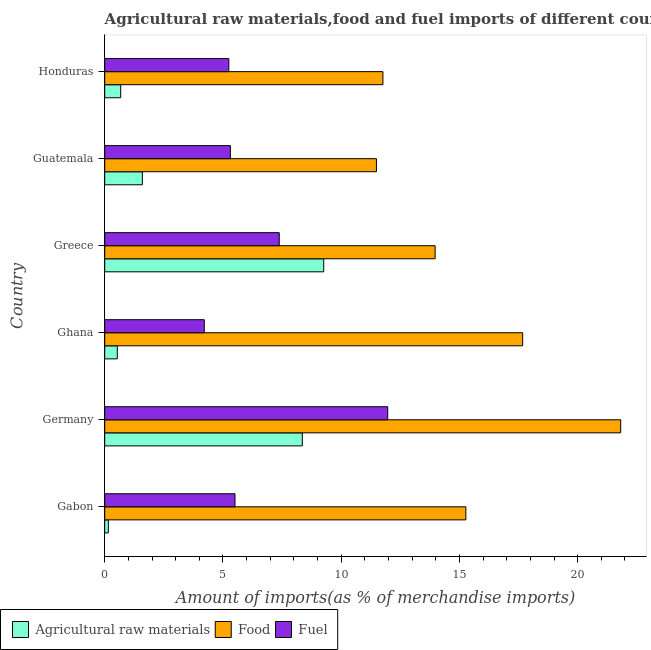Are the number of bars per tick equal to the number of legend labels?
Offer a terse response. Yes. Are the number of bars on each tick of the Y-axis equal?
Provide a short and direct response. Yes. What is the percentage of fuel imports in Ghana?
Keep it short and to the point. 4.21. Across all countries, what is the maximum percentage of raw materials imports?
Give a very brief answer. 9.26. Across all countries, what is the minimum percentage of food imports?
Your response must be concise. 11.49. In which country was the percentage of food imports minimum?
Make the answer very short. Guatemala. What is the total percentage of food imports in the graph?
Provide a succinct answer. 91.99. What is the difference between the percentage of fuel imports in Gabon and that in Honduras?
Provide a short and direct response. 0.26. What is the difference between the percentage of fuel imports in Guatemala and the percentage of food imports in Ghana?
Your answer should be very brief. -12.36. What is the average percentage of raw materials imports per country?
Make the answer very short. 3.43. What is the difference between the percentage of raw materials imports and percentage of fuel imports in Gabon?
Keep it short and to the point. -5.36. In how many countries, is the percentage of raw materials imports greater than 21 %?
Offer a very short reply. 0. What is the ratio of the percentage of raw materials imports in Gabon to that in Honduras?
Your answer should be compact. 0.23. Is the percentage of food imports in Guatemala less than that in Honduras?
Ensure brevity in your answer.  Yes. What is the difference between the highest and the second highest percentage of fuel imports?
Provide a short and direct response. 4.59. What is the difference between the highest and the lowest percentage of raw materials imports?
Provide a succinct answer. 9.11. In how many countries, is the percentage of raw materials imports greater than the average percentage of raw materials imports taken over all countries?
Give a very brief answer. 2. Is the sum of the percentage of fuel imports in Guatemala and Honduras greater than the maximum percentage of food imports across all countries?
Provide a short and direct response. No. What does the 3rd bar from the top in Gabon represents?
Keep it short and to the point. Agricultural raw materials. What does the 2nd bar from the bottom in Ghana represents?
Provide a succinct answer. Food. How many bars are there?
Your answer should be very brief. 18. How many countries are there in the graph?
Your response must be concise. 6. What is the difference between two consecutive major ticks on the X-axis?
Give a very brief answer. 5. Does the graph contain grids?
Offer a very short reply. No. Where does the legend appear in the graph?
Offer a terse response. Bottom left. What is the title of the graph?
Provide a short and direct response. Agricultural raw materials,food and fuel imports of different countries in 1966. Does "Slovak Republic" appear as one of the legend labels in the graph?
Your answer should be very brief. No. What is the label or title of the X-axis?
Ensure brevity in your answer.  Amount of imports(as % of merchandise imports). What is the label or title of the Y-axis?
Provide a succinct answer. Country. What is the Amount of imports(as % of merchandise imports) of Agricultural raw materials in Gabon?
Give a very brief answer. 0.15. What is the Amount of imports(as % of merchandise imports) in Food in Gabon?
Your answer should be compact. 15.27. What is the Amount of imports(as % of merchandise imports) in Fuel in Gabon?
Offer a very short reply. 5.51. What is the Amount of imports(as % of merchandise imports) in Agricultural raw materials in Germany?
Give a very brief answer. 8.36. What is the Amount of imports(as % of merchandise imports) in Food in Germany?
Provide a short and direct response. 21.82. What is the Amount of imports(as % of merchandise imports) in Fuel in Germany?
Offer a very short reply. 11.97. What is the Amount of imports(as % of merchandise imports) in Agricultural raw materials in Ghana?
Offer a terse response. 0.53. What is the Amount of imports(as % of merchandise imports) of Food in Ghana?
Provide a short and direct response. 17.67. What is the Amount of imports(as % of merchandise imports) of Fuel in Ghana?
Give a very brief answer. 4.21. What is the Amount of imports(as % of merchandise imports) of Agricultural raw materials in Greece?
Your answer should be compact. 9.26. What is the Amount of imports(as % of merchandise imports) in Food in Greece?
Make the answer very short. 13.97. What is the Amount of imports(as % of merchandise imports) of Fuel in Greece?
Provide a short and direct response. 7.38. What is the Amount of imports(as % of merchandise imports) of Agricultural raw materials in Guatemala?
Offer a very short reply. 1.59. What is the Amount of imports(as % of merchandise imports) of Food in Guatemala?
Ensure brevity in your answer.  11.49. What is the Amount of imports(as % of merchandise imports) in Fuel in Guatemala?
Provide a short and direct response. 5.31. What is the Amount of imports(as % of merchandise imports) in Agricultural raw materials in Honduras?
Keep it short and to the point. 0.68. What is the Amount of imports(as % of merchandise imports) in Food in Honduras?
Your answer should be compact. 11.76. What is the Amount of imports(as % of merchandise imports) of Fuel in Honduras?
Keep it short and to the point. 5.25. Across all countries, what is the maximum Amount of imports(as % of merchandise imports) in Agricultural raw materials?
Give a very brief answer. 9.26. Across all countries, what is the maximum Amount of imports(as % of merchandise imports) of Food?
Your answer should be very brief. 21.82. Across all countries, what is the maximum Amount of imports(as % of merchandise imports) of Fuel?
Provide a succinct answer. 11.97. Across all countries, what is the minimum Amount of imports(as % of merchandise imports) of Agricultural raw materials?
Offer a very short reply. 0.15. Across all countries, what is the minimum Amount of imports(as % of merchandise imports) of Food?
Your answer should be compact. 11.49. Across all countries, what is the minimum Amount of imports(as % of merchandise imports) in Fuel?
Your response must be concise. 4.21. What is the total Amount of imports(as % of merchandise imports) in Agricultural raw materials in the graph?
Make the answer very short. 20.57. What is the total Amount of imports(as % of merchandise imports) of Food in the graph?
Your answer should be compact. 91.99. What is the total Amount of imports(as % of merchandise imports) in Fuel in the graph?
Your answer should be very brief. 39.63. What is the difference between the Amount of imports(as % of merchandise imports) of Agricultural raw materials in Gabon and that in Germany?
Offer a very short reply. -8.2. What is the difference between the Amount of imports(as % of merchandise imports) in Food in Gabon and that in Germany?
Your response must be concise. -6.55. What is the difference between the Amount of imports(as % of merchandise imports) in Fuel in Gabon and that in Germany?
Your answer should be very brief. -6.46. What is the difference between the Amount of imports(as % of merchandise imports) in Agricultural raw materials in Gabon and that in Ghana?
Keep it short and to the point. -0.38. What is the difference between the Amount of imports(as % of merchandise imports) of Food in Gabon and that in Ghana?
Ensure brevity in your answer.  -2.4. What is the difference between the Amount of imports(as % of merchandise imports) of Fuel in Gabon and that in Ghana?
Offer a very short reply. 1.3. What is the difference between the Amount of imports(as % of merchandise imports) of Agricultural raw materials in Gabon and that in Greece?
Provide a short and direct response. -9.11. What is the difference between the Amount of imports(as % of merchandise imports) in Food in Gabon and that in Greece?
Your answer should be very brief. 1.3. What is the difference between the Amount of imports(as % of merchandise imports) in Fuel in Gabon and that in Greece?
Your answer should be very brief. -1.87. What is the difference between the Amount of imports(as % of merchandise imports) in Agricultural raw materials in Gabon and that in Guatemala?
Provide a succinct answer. -1.44. What is the difference between the Amount of imports(as % of merchandise imports) in Food in Gabon and that in Guatemala?
Offer a terse response. 3.78. What is the difference between the Amount of imports(as % of merchandise imports) in Fuel in Gabon and that in Guatemala?
Keep it short and to the point. 0.2. What is the difference between the Amount of imports(as % of merchandise imports) of Agricultural raw materials in Gabon and that in Honduras?
Ensure brevity in your answer.  -0.52. What is the difference between the Amount of imports(as % of merchandise imports) of Food in Gabon and that in Honduras?
Keep it short and to the point. 3.51. What is the difference between the Amount of imports(as % of merchandise imports) in Fuel in Gabon and that in Honduras?
Make the answer very short. 0.26. What is the difference between the Amount of imports(as % of merchandise imports) of Agricultural raw materials in Germany and that in Ghana?
Provide a succinct answer. 7.82. What is the difference between the Amount of imports(as % of merchandise imports) of Food in Germany and that in Ghana?
Offer a very short reply. 4.14. What is the difference between the Amount of imports(as % of merchandise imports) in Fuel in Germany and that in Ghana?
Provide a succinct answer. 7.76. What is the difference between the Amount of imports(as % of merchandise imports) of Agricultural raw materials in Germany and that in Greece?
Your answer should be compact. -0.91. What is the difference between the Amount of imports(as % of merchandise imports) in Food in Germany and that in Greece?
Your answer should be compact. 7.85. What is the difference between the Amount of imports(as % of merchandise imports) in Fuel in Germany and that in Greece?
Provide a short and direct response. 4.59. What is the difference between the Amount of imports(as % of merchandise imports) of Agricultural raw materials in Germany and that in Guatemala?
Offer a very short reply. 6.76. What is the difference between the Amount of imports(as % of merchandise imports) in Food in Germany and that in Guatemala?
Your answer should be compact. 10.33. What is the difference between the Amount of imports(as % of merchandise imports) of Fuel in Germany and that in Guatemala?
Your answer should be very brief. 6.65. What is the difference between the Amount of imports(as % of merchandise imports) of Agricultural raw materials in Germany and that in Honduras?
Give a very brief answer. 7.68. What is the difference between the Amount of imports(as % of merchandise imports) in Food in Germany and that in Honduras?
Your response must be concise. 10.05. What is the difference between the Amount of imports(as % of merchandise imports) in Fuel in Germany and that in Honduras?
Your answer should be very brief. 6.72. What is the difference between the Amount of imports(as % of merchandise imports) in Agricultural raw materials in Ghana and that in Greece?
Provide a short and direct response. -8.73. What is the difference between the Amount of imports(as % of merchandise imports) in Food in Ghana and that in Greece?
Provide a succinct answer. 3.7. What is the difference between the Amount of imports(as % of merchandise imports) in Fuel in Ghana and that in Greece?
Your answer should be very brief. -3.17. What is the difference between the Amount of imports(as % of merchandise imports) in Agricultural raw materials in Ghana and that in Guatemala?
Make the answer very short. -1.06. What is the difference between the Amount of imports(as % of merchandise imports) of Food in Ghana and that in Guatemala?
Give a very brief answer. 6.18. What is the difference between the Amount of imports(as % of merchandise imports) in Fuel in Ghana and that in Guatemala?
Ensure brevity in your answer.  -1.1. What is the difference between the Amount of imports(as % of merchandise imports) in Agricultural raw materials in Ghana and that in Honduras?
Make the answer very short. -0.14. What is the difference between the Amount of imports(as % of merchandise imports) in Food in Ghana and that in Honduras?
Make the answer very short. 5.91. What is the difference between the Amount of imports(as % of merchandise imports) in Fuel in Ghana and that in Honduras?
Ensure brevity in your answer.  -1.04. What is the difference between the Amount of imports(as % of merchandise imports) of Agricultural raw materials in Greece and that in Guatemala?
Offer a very short reply. 7.67. What is the difference between the Amount of imports(as % of merchandise imports) in Food in Greece and that in Guatemala?
Make the answer very short. 2.48. What is the difference between the Amount of imports(as % of merchandise imports) of Fuel in Greece and that in Guatemala?
Provide a succinct answer. 2.07. What is the difference between the Amount of imports(as % of merchandise imports) in Agricultural raw materials in Greece and that in Honduras?
Make the answer very short. 8.59. What is the difference between the Amount of imports(as % of merchandise imports) of Food in Greece and that in Honduras?
Ensure brevity in your answer.  2.21. What is the difference between the Amount of imports(as % of merchandise imports) of Fuel in Greece and that in Honduras?
Your response must be concise. 2.13. What is the difference between the Amount of imports(as % of merchandise imports) in Agricultural raw materials in Guatemala and that in Honduras?
Make the answer very short. 0.92. What is the difference between the Amount of imports(as % of merchandise imports) in Food in Guatemala and that in Honduras?
Your answer should be compact. -0.28. What is the difference between the Amount of imports(as % of merchandise imports) in Fuel in Guatemala and that in Honduras?
Provide a succinct answer. 0.06. What is the difference between the Amount of imports(as % of merchandise imports) in Agricultural raw materials in Gabon and the Amount of imports(as % of merchandise imports) in Food in Germany?
Provide a succinct answer. -21.67. What is the difference between the Amount of imports(as % of merchandise imports) of Agricultural raw materials in Gabon and the Amount of imports(as % of merchandise imports) of Fuel in Germany?
Offer a terse response. -11.81. What is the difference between the Amount of imports(as % of merchandise imports) in Food in Gabon and the Amount of imports(as % of merchandise imports) in Fuel in Germany?
Give a very brief answer. 3.3. What is the difference between the Amount of imports(as % of merchandise imports) in Agricultural raw materials in Gabon and the Amount of imports(as % of merchandise imports) in Food in Ghana?
Provide a short and direct response. -17.52. What is the difference between the Amount of imports(as % of merchandise imports) of Agricultural raw materials in Gabon and the Amount of imports(as % of merchandise imports) of Fuel in Ghana?
Make the answer very short. -4.06. What is the difference between the Amount of imports(as % of merchandise imports) in Food in Gabon and the Amount of imports(as % of merchandise imports) in Fuel in Ghana?
Give a very brief answer. 11.06. What is the difference between the Amount of imports(as % of merchandise imports) of Agricultural raw materials in Gabon and the Amount of imports(as % of merchandise imports) of Food in Greece?
Give a very brief answer. -13.82. What is the difference between the Amount of imports(as % of merchandise imports) in Agricultural raw materials in Gabon and the Amount of imports(as % of merchandise imports) in Fuel in Greece?
Offer a very short reply. -7.23. What is the difference between the Amount of imports(as % of merchandise imports) of Food in Gabon and the Amount of imports(as % of merchandise imports) of Fuel in Greece?
Your answer should be compact. 7.89. What is the difference between the Amount of imports(as % of merchandise imports) of Agricultural raw materials in Gabon and the Amount of imports(as % of merchandise imports) of Food in Guatemala?
Keep it short and to the point. -11.34. What is the difference between the Amount of imports(as % of merchandise imports) of Agricultural raw materials in Gabon and the Amount of imports(as % of merchandise imports) of Fuel in Guatemala?
Make the answer very short. -5.16. What is the difference between the Amount of imports(as % of merchandise imports) in Food in Gabon and the Amount of imports(as % of merchandise imports) in Fuel in Guatemala?
Your answer should be compact. 9.96. What is the difference between the Amount of imports(as % of merchandise imports) in Agricultural raw materials in Gabon and the Amount of imports(as % of merchandise imports) in Food in Honduras?
Give a very brief answer. -11.61. What is the difference between the Amount of imports(as % of merchandise imports) in Agricultural raw materials in Gabon and the Amount of imports(as % of merchandise imports) in Fuel in Honduras?
Offer a terse response. -5.09. What is the difference between the Amount of imports(as % of merchandise imports) in Food in Gabon and the Amount of imports(as % of merchandise imports) in Fuel in Honduras?
Make the answer very short. 10.02. What is the difference between the Amount of imports(as % of merchandise imports) in Agricultural raw materials in Germany and the Amount of imports(as % of merchandise imports) in Food in Ghana?
Keep it short and to the point. -9.32. What is the difference between the Amount of imports(as % of merchandise imports) in Agricultural raw materials in Germany and the Amount of imports(as % of merchandise imports) in Fuel in Ghana?
Your response must be concise. 4.15. What is the difference between the Amount of imports(as % of merchandise imports) of Food in Germany and the Amount of imports(as % of merchandise imports) of Fuel in Ghana?
Give a very brief answer. 17.61. What is the difference between the Amount of imports(as % of merchandise imports) of Agricultural raw materials in Germany and the Amount of imports(as % of merchandise imports) of Food in Greece?
Give a very brief answer. -5.62. What is the difference between the Amount of imports(as % of merchandise imports) in Agricultural raw materials in Germany and the Amount of imports(as % of merchandise imports) in Fuel in Greece?
Your response must be concise. 0.97. What is the difference between the Amount of imports(as % of merchandise imports) in Food in Germany and the Amount of imports(as % of merchandise imports) in Fuel in Greece?
Offer a very short reply. 14.44. What is the difference between the Amount of imports(as % of merchandise imports) in Agricultural raw materials in Germany and the Amount of imports(as % of merchandise imports) in Food in Guatemala?
Your answer should be compact. -3.13. What is the difference between the Amount of imports(as % of merchandise imports) of Agricultural raw materials in Germany and the Amount of imports(as % of merchandise imports) of Fuel in Guatemala?
Your answer should be very brief. 3.04. What is the difference between the Amount of imports(as % of merchandise imports) in Food in Germany and the Amount of imports(as % of merchandise imports) in Fuel in Guatemala?
Offer a very short reply. 16.51. What is the difference between the Amount of imports(as % of merchandise imports) in Agricultural raw materials in Germany and the Amount of imports(as % of merchandise imports) in Food in Honduras?
Make the answer very short. -3.41. What is the difference between the Amount of imports(as % of merchandise imports) in Agricultural raw materials in Germany and the Amount of imports(as % of merchandise imports) in Fuel in Honduras?
Make the answer very short. 3.11. What is the difference between the Amount of imports(as % of merchandise imports) in Food in Germany and the Amount of imports(as % of merchandise imports) in Fuel in Honduras?
Offer a terse response. 16.57. What is the difference between the Amount of imports(as % of merchandise imports) of Agricultural raw materials in Ghana and the Amount of imports(as % of merchandise imports) of Food in Greece?
Offer a very short reply. -13.44. What is the difference between the Amount of imports(as % of merchandise imports) in Agricultural raw materials in Ghana and the Amount of imports(as % of merchandise imports) in Fuel in Greece?
Provide a short and direct response. -6.85. What is the difference between the Amount of imports(as % of merchandise imports) of Food in Ghana and the Amount of imports(as % of merchandise imports) of Fuel in Greece?
Provide a short and direct response. 10.29. What is the difference between the Amount of imports(as % of merchandise imports) of Agricultural raw materials in Ghana and the Amount of imports(as % of merchandise imports) of Food in Guatemala?
Offer a very short reply. -10.96. What is the difference between the Amount of imports(as % of merchandise imports) of Agricultural raw materials in Ghana and the Amount of imports(as % of merchandise imports) of Fuel in Guatemala?
Your answer should be compact. -4.78. What is the difference between the Amount of imports(as % of merchandise imports) in Food in Ghana and the Amount of imports(as % of merchandise imports) in Fuel in Guatemala?
Keep it short and to the point. 12.36. What is the difference between the Amount of imports(as % of merchandise imports) in Agricultural raw materials in Ghana and the Amount of imports(as % of merchandise imports) in Food in Honduras?
Offer a terse response. -11.23. What is the difference between the Amount of imports(as % of merchandise imports) in Agricultural raw materials in Ghana and the Amount of imports(as % of merchandise imports) in Fuel in Honduras?
Your answer should be very brief. -4.72. What is the difference between the Amount of imports(as % of merchandise imports) in Food in Ghana and the Amount of imports(as % of merchandise imports) in Fuel in Honduras?
Provide a succinct answer. 12.43. What is the difference between the Amount of imports(as % of merchandise imports) of Agricultural raw materials in Greece and the Amount of imports(as % of merchandise imports) of Food in Guatemala?
Offer a very short reply. -2.23. What is the difference between the Amount of imports(as % of merchandise imports) in Agricultural raw materials in Greece and the Amount of imports(as % of merchandise imports) in Fuel in Guatemala?
Offer a very short reply. 3.95. What is the difference between the Amount of imports(as % of merchandise imports) in Food in Greece and the Amount of imports(as % of merchandise imports) in Fuel in Guatemala?
Give a very brief answer. 8.66. What is the difference between the Amount of imports(as % of merchandise imports) in Agricultural raw materials in Greece and the Amount of imports(as % of merchandise imports) in Food in Honduras?
Your response must be concise. -2.5. What is the difference between the Amount of imports(as % of merchandise imports) in Agricultural raw materials in Greece and the Amount of imports(as % of merchandise imports) in Fuel in Honduras?
Ensure brevity in your answer.  4.01. What is the difference between the Amount of imports(as % of merchandise imports) of Food in Greece and the Amount of imports(as % of merchandise imports) of Fuel in Honduras?
Keep it short and to the point. 8.72. What is the difference between the Amount of imports(as % of merchandise imports) in Agricultural raw materials in Guatemala and the Amount of imports(as % of merchandise imports) in Food in Honduras?
Ensure brevity in your answer.  -10.17. What is the difference between the Amount of imports(as % of merchandise imports) in Agricultural raw materials in Guatemala and the Amount of imports(as % of merchandise imports) in Fuel in Honduras?
Offer a terse response. -3.66. What is the difference between the Amount of imports(as % of merchandise imports) of Food in Guatemala and the Amount of imports(as % of merchandise imports) of Fuel in Honduras?
Offer a terse response. 6.24. What is the average Amount of imports(as % of merchandise imports) of Agricultural raw materials per country?
Keep it short and to the point. 3.43. What is the average Amount of imports(as % of merchandise imports) in Food per country?
Your response must be concise. 15.33. What is the average Amount of imports(as % of merchandise imports) in Fuel per country?
Provide a succinct answer. 6.6. What is the difference between the Amount of imports(as % of merchandise imports) of Agricultural raw materials and Amount of imports(as % of merchandise imports) of Food in Gabon?
Your answer should be very brief. -15.12. What is the difference between the Amount of imports(as % of merchandise imports) in Agricultural raw materials and Amount of imports(as % of merchandise imports) in Fuel in Gabon?
Keep it short and to the point. -5.36. What is the difference between the Amount of imports(as % of merchandise imports) of Food and Amount of imports(as % of merchandise imports) of Fuel in Gabon?
Keep it short and to the point. 9.76. What is the difference between the Amount of imports(as % of merchandise imports) in Agricultural raw materials and Amount of imports(as % of merchandise imports) in Food in Germany?
Offer a very short reply. -13.46. What is the difference between the Amount of imports(as % of merchandise imports) in Agricultural raw materials and Amount of imports(as % of merchandise imports) in Fuel in Germany?
Make the answer very short. -3.61. What is the difference between the Amount of imports(as % of merchandise imports) in Food and Amount of imports(as % of merchandise imports) in Fuel in Germany?
Give a very brief answer. 9.85. What is the difference between the Amount of imports(as % of merchandise imports) in Agricultural raw materials and Amount of imports(as % of merchandise imports) in Food in Ghana?
Your answer should be very brief. -17.14. What is the difference between the Amount of imports(as % of merchandise imports) of Agricultural raw materials and Amount of imports(as % of merchandise imports) of Fuel in Ghana?
Offer a terse response. -3.68. What is the difference between the Amount of imports(as % of merchandise imports) in Food and Amount of imports(as % of merchandise imports) in Fuel in Ghana?
Your answer should be compact. 13.46. What is the difference between the Amount of imports(as % of merchandise imports) in Agricultural raw materials and Amount of imports(as % of merchandise imports) in Food in Greece?
Your response must be concise. -4.71. What is the difference between the Amount of imports(as % of merchandise imports) of Agricultural raw materials and Amount of imports(as % of merchandise imports) of Fuel in Greece?
Make the answer very short. 1.88. What is the difference between the Amount of imports(as % of merchandise imports) in Food and Amount of imports(as % of merchandise imports) in Fuel in Greece?
Your answer should be very brief. 6.59. What is the difference between the Amount of imports(as % of merchandise imports) of Agricultural raw materials and Amount of imports(as % of merchandise imports) of Food in Guatemala?
Your answer should be very brief. -9.9. What is the difference between the Amount of imports(as % of merchandise imports) in Agricultural raw materials and Amount of imports(as % of merchandise imports) in Fuel in Guatemala?
Provide a short and direct response. -3.72. What is the difference between the Amount of imports(as % of merchandise imports) in Food and Amount of imports(as % of merchandise imports) in Fuel in Guatemala?
Give a very brief answer. 6.18. What is the difference between the Amount of imports(as % of merchandise imports) of Agricultural raw materials and Amount of imports(as % of merchandise imports) of Food in Honduras?
Your response must be concise. -11.09. What is the difference between the Amount of imports(as % of merchandise imports) of Agricultural raw materials and Amount of imports(as % of merchandise imports) of Fuel in Honduras?
Ensure brevity in your answer.  -4.57. What is the difference between the Amount of imports(as % of merchandise imports) of Food and Amount of imports(as % of merchandise imports) of Fuel in Honduras?
Provide a succinct answer. 6.52. What is the ratio of the Amount of imports(as % of merchandise imports) in Agricultural raw materials in Gabon to that in Germany?
Provide a short and direct response. 0.02. What is the ratio of the Amount of imports(as % of merchandise imports) of Food in Gabon to that in Germany?
Ensure brevity in your answer.  0.7. What is the ratio of the Amount of imports(as % of merchandise imports) of Fuel in Gabon to that in Germany?
Give a very brief answer. 0.46. What is the ratio of the Amount of imports(as % of merchandise imports) in Agricultural raw materials in Gabon to that in Ghana?
Make the answer very short. 0.29. What is the ratio of the Amount of imports(as % of merchandise imports) of Food in Gabon to that in Ghana?
Offer a terse response. 0.86. What is the ratio of the Amount of imports(as % of merchandise imports) of Fuel in Gabon to that in Ghana?
Provide a short and direct response. 1.31. What is the ratio of the Amount of imports(as % of merchandise imports) of Agricultural raw materials in Gabon to that in Greece?
Offer a very short reply. 0.02. What is the ratio of the Amount of imports(as % of merchandise imports) in Food in Gabon to that in Greece?
Offer a very short reply. 1.09. What is the ratio of the Amount of imports(as % of merchandise imports) of Fuel in Gabon to that in Greece?
Ensure brevity in your answer.  0.75. What is the ratio of the Amount of imports(as % of merchandise imports) in Agricultural raw materials in Gabon to that in Guatemala?
Provide a succinct answer. 0.1. What is the ratio of the Amount of imports(as % of merchandise imports) in Food in Gabon to that in Guatemala?
Keep it short and to the point. 1.33. What is the ratio of the Amount of imports(as % of merchandise imports) of Fuel in Gabon to that in Guatemala?
Offer a terse response. 1.04. What is the ratio of the Amount of imports(as % of merchandise imports) of Agricultural raw materials in Gabon to that in Honduras?
Provide a short and direct response. 0.23. What is the ratio of the Amount of imports(as % of merchandise imports) of Food in Gabon to that in Honduras?
Ensure brevity in your answer.  1.3. What is the ratio of the Amount of imports(as % of merchandise imports) of Fuel in Gabon to that in Honduras?
Make the answer very short. 1.05. What is the ratio of the Amount of imports(as % of merchandise imports) in Agricultural raw materials in Germany to that in Ghana?
Offer a terse response. 15.72. What is the ratio of the Amount of imports(as % of merchandise imports) of Food in Germany to that in Ghana?
Give a very brief answer. 1.23. What is the ratio of the Amount of imports(as % of merchandise imports) in Fuel in Germany to that in Ghana?
Your answer should be very brief. 2.84. What is the ratio of the Amount of imports(as % of merchandise imports) of Agricultural raw materials in Germany to that in Greece?
Give a very brief answer. 0.9. What is the ratio of the Amount of imports(as % of merchandise imports) of Food in Germany to that in Greece?
Give a very brief answer. 1.56. What is the ratio of the Amount of imports(as % of merchandise imports) of Fuel in Germany to that in Greece?
Make the answer very short. 1.62. What is the ratio of the Amount of imports(as % of merchandise imports) in Agricultural raw materials in Germany to that in Guatemala?
Keep it short and to the point. 5.25. What is the ratio of the Amount of imports(as % of merchandise imports) of Food in Germany to that in Guatemala?
Offer a very short reply. 1.9. What is the ratio of the Amount of imports(as % of merchandise imports) of Fuel in Germany to that in Guatemala?
Offer a very short reply. 2.25. What is the ratio of the Amount of imports(as % of merchandise imports) in Agricultural raw materials in Germany to that in Honduras?
Keep it short and to the point. 12.37. What is the ratio of the Amount of imports(as % of merchandise imports) of Food in Germany to that in Honduras?
Make the answer very short. 1.85. What is the ratio of the Amount of imports(as % of merchandise imports) in Fuel in Germany to that in Honduras?
Offer a very short reply. 2.28. What is the ratio of the Amount of imports(as % of merchandise imports) of Agricultural raw materials in Ghana to that in Greece?
Provide a short and direct response. 0.06. What is the ratio of the Amount of imports(as % of merchandise imports) in Food in Ghana to that in Greece?
Make the answer very short. 1.26. What is the ratio of the Amount of imports(as % of merchandise imports) of Fuel in Ghana to that in Greece?
Offer a very short reply. 0.57. What is the ratio of the Amount of imports(as % of merchandise imports) of Agricultural raw materials in Ghana to that in Guatemala?
Make the answer very short. 0.33. What is the ratio of the Amount of imports(as % of merchandise imports) in Food in Ghana to that in Guatemala?
Provide a short and direct response. 1.54. What is the ratio of the Amount of imports(as % of merchandise imports) in Fuel in Ghana to that in Guatemala?
Your response must be concise. 0.79. What is the ratio of the Amount of imports(as % of merchandise imports) of Agricultural raw materials in Ghana to that in Honduras?
Your response must be concise. 0.79. What is the ratio of the Amount of imports(as % of merchandise imports) in Food in Ghana to that in Honduras?
Your answer should be very brief. 1.5. What is the ratio of the Amount of imports(as % of merchandise imports) of Fuel in Ghana to that in Honduras?
Ensure brevity in your answer.  0.8. What is the ratio of the Amount of imports(as % of merchandise imports) in Agricultural raw materials in Greece to that in Guatemala?
Keep it short and to the point. 5.82. What is the ratio of the Amount of imports(as % of merchandise imports) of Food in Greece to that in Guatemala?
Keep it short and to the point. 1.22. What is the ratio of the Amount of imports(as % of merchandise imports) in Fuel in Greece to that in Guatemala?
Offer a very short reply. 1.39. What is the ratio of the Amount of imports(as % of merchandise imports) in Agricultural raw materials in Greece to that in Honduras?
Your answer should be compact. 13.71. What is the ratio of the Amount of imports(as % of merchandise imports) in Food in Greece to that in Honduras?
Offer a terse response. 1.19. What is the ratio of the Amount of imports(as % of merchandise imports) of Fuel in Greece to that in Honduras?
Ensure brevity in your answer.  1.41. What is the ratio of the Amount of imports(as % of merchandise imports) in Agricultural raw materials in Guatemala to that in Honduras?
Offer a very short reply. 2.36. What is the ratio of the Amount of imports(as % of merchandise imports) of Food in Guatemala to that in Honduras?
Your answer should be compact. 0.98. What is the ratio of the Amount of imports(as % of merchandise imports) in Fuel in Guatemala to that in Honduras?
Offer a very short reply. 1.01. What is the difference between the highest and the second highest Amount of imports(as % of merchandise imports) in Agricultural raw materials?
Make the answer very short. 0.91. What is the difference between the highest and the second highest Amount of imports(as % of merchandise imports) in Food?
Offer a very short reply. 4.14. What is the difference between the highest and the second highest Amount of imports(as % of merchandise imports) of Fuel?
Offer a very short reply. 4.59. What is the difference between the highest and the lowest Amount of imports(as % of merchandise imports) in Agricultural raw materials?
Provide a short and direct response. 9.11. What is the difference between the highest and the lowest Amount of imports(as % of merchandise imports) of Food?
Ensure brevity in your answer.  10.33. What is the difference between the highest and the lowest Amount of imports(as % of merchandise imports) of Fuel?
Give a very brief answer. 7.76. 